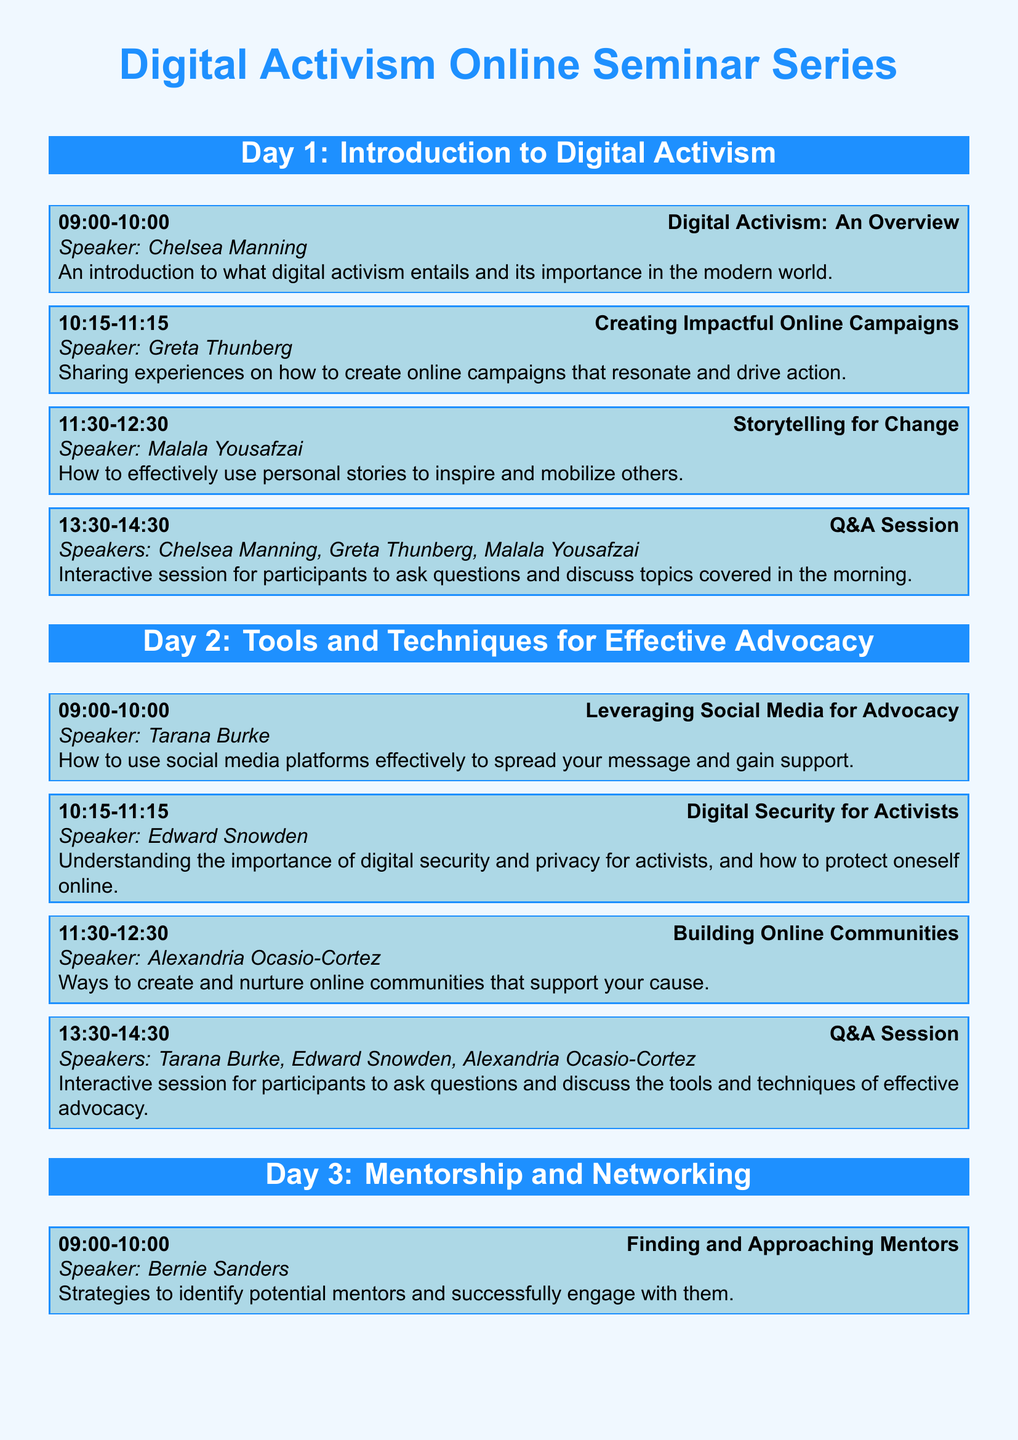What is the title of the seminar series? The title of the seminar series is stated at the top of the document.
Answer: Digital Activism Online Seminar Series Who is the speaker for the session on "Digital Security for Activists"? The speaker for this session is mentioned in the session details.
Answer: Edward Snowden What time does the "Collaborative Advocacy Projects" session start? The start time for this session is listed in the schedule under Day 3.
Answer: 11:30 How many days does the seminar series last? The number of days can be counted from the day headers in the document.
Answer: 3 Which speaker discusses "Creating Impactful Online Campaigns"? The speaker for this session is found in the corresponding session block.
Answer: Greta Thunberg What topic is addressed during the Q&A Session on Day 1? The topics covered during the Q&A are listed in the session description.
Answer: Topics covered in the morning What session follows "Finding and Approaching Mentors"? The subsequent session is detailed in the session listing.
Answer: Building Your Advocacy Network In which session is storytelling emphasized? The session focusing on storytelling is specified in the title of one of the blocks.
Answer: Storytelling for Change 